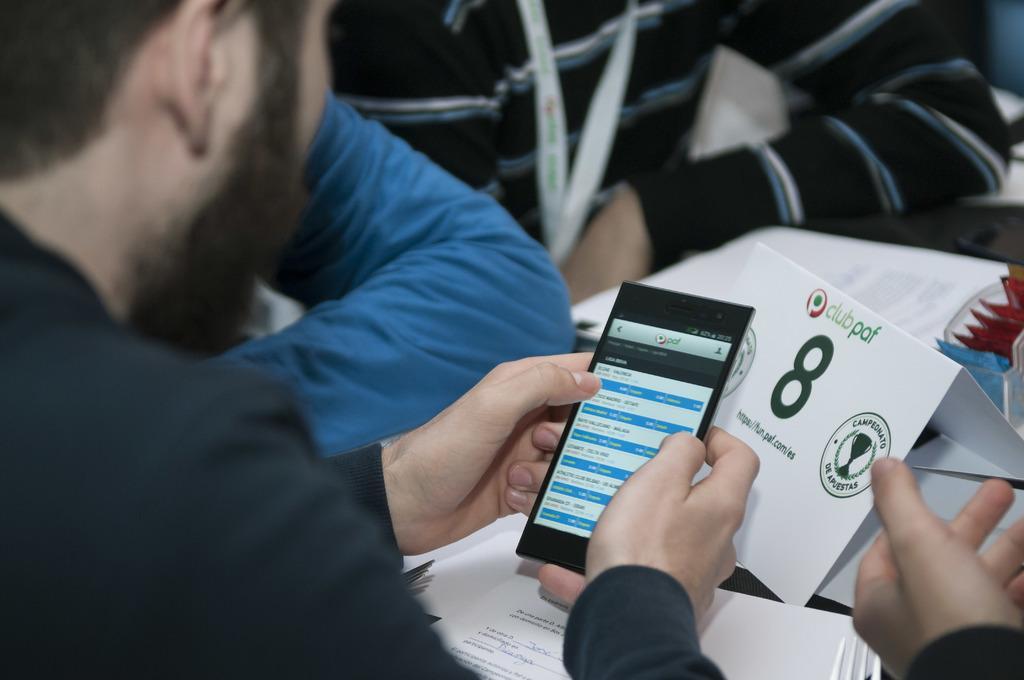Could you give a brief overview of what you see in this image? Here we can see three persons. He is holding a mobile with his hands. These are the papers. 